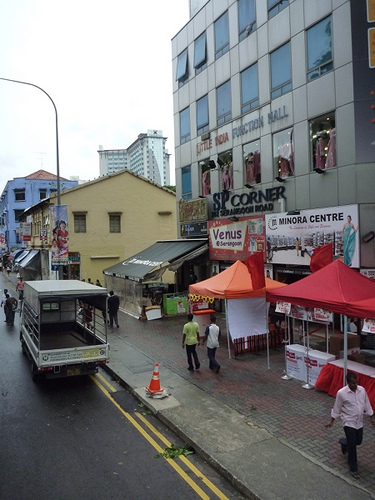<image>
Is there a window on the building? No. The window is not positioned on the building. They may be near each other, but the window is not supported by or resting on top of the building. 